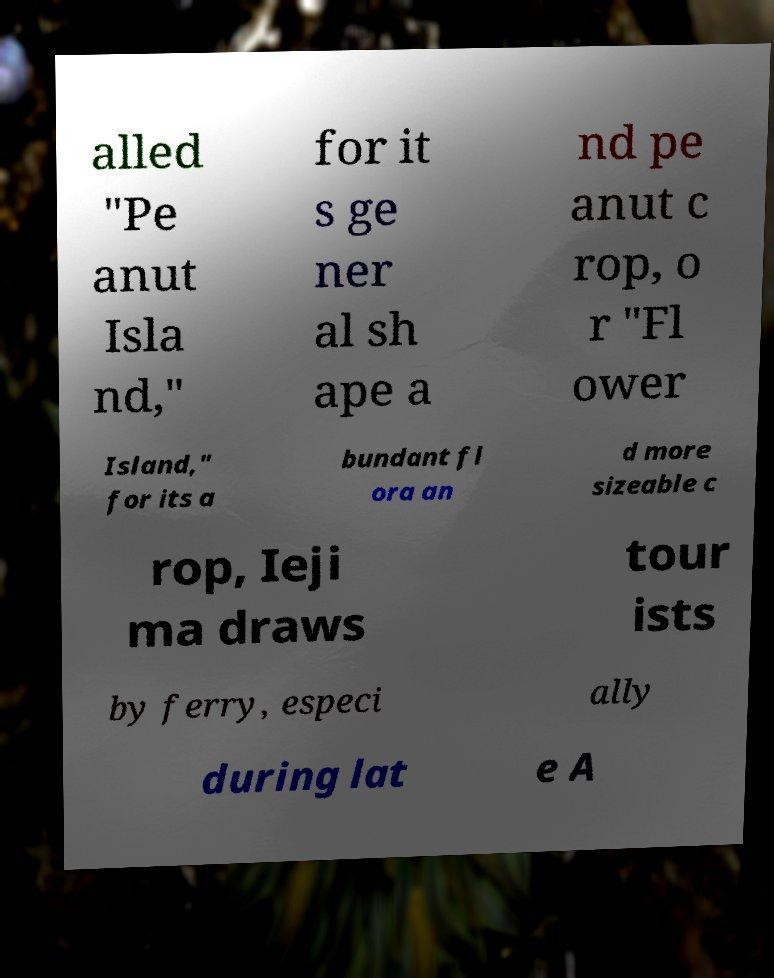Can you read and provide the text displayed in the image?This photo seems to have some interesting text. Can you extract and type it out for me? alled "Pe anut Isla nd," for it s ge ner al sh ape a nd pe anut c rop, o r "Fl ower Island," for its a bundant fl ora an d more sizeable c rop, Ieji ma draws tour ists by ferry, especi ally during lat e A 